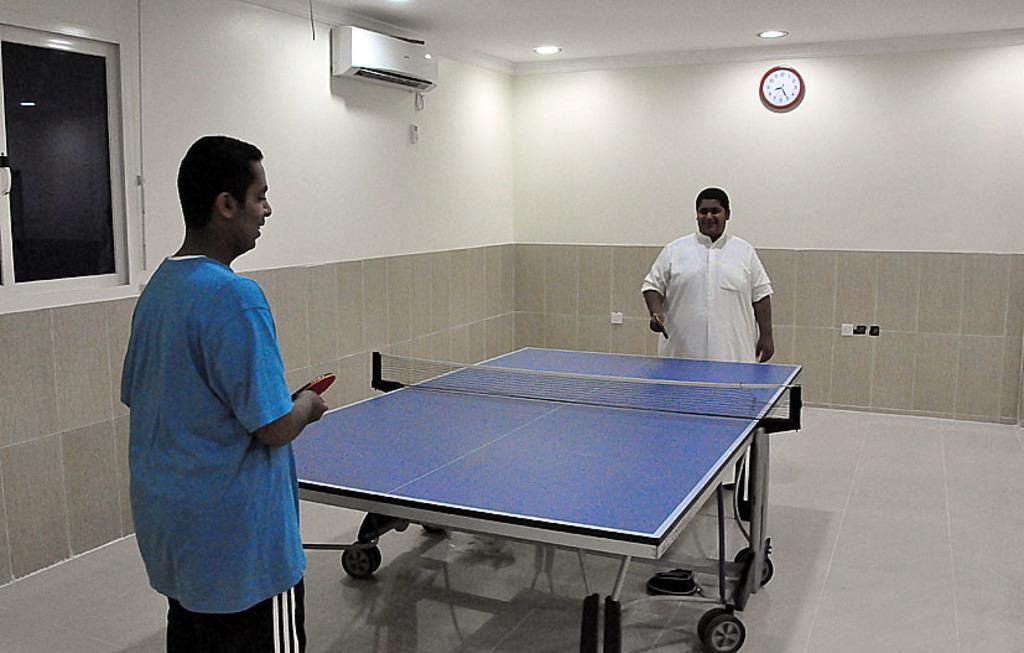Describe this image in one or two sentences. The two persons holding table tennis bats and there is a table in front of them and there is a watch and ac attached to the wall in the background. 